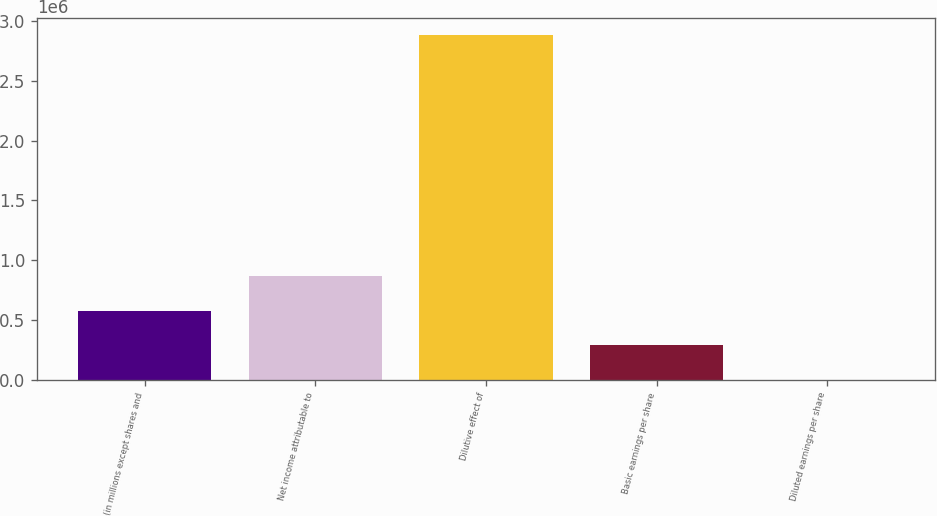Convert chart. <chart><loc_0><loc_0><loc_500><loc_500><bar_chart><fcel>(in millions except shares and<fcel>Net income attributable to<fcel>Dilutive effect of<fcel>Basic earnings per share<fcel>Diluted earnings per share<nl><fcel>577437<fcel>866146<fcel>2.88711e+06<fcel>288728<fcel>19.25<nl></chart> 